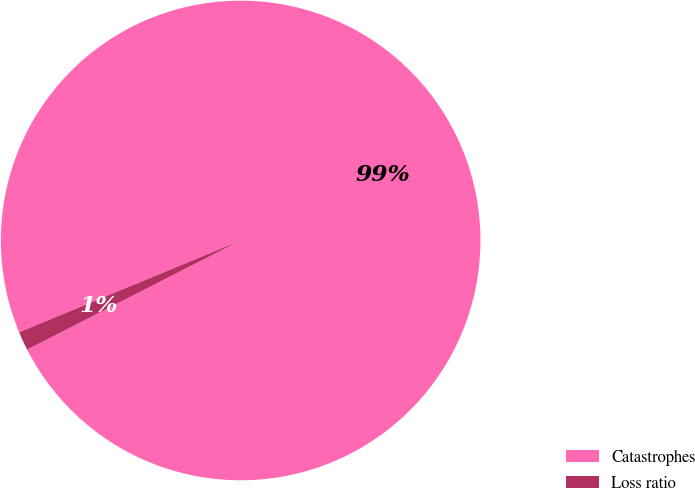Convert chart to OTSL. <chart><loc_0><loc_0><loc_500><loc_500><pie_chart><fcel>Catastrophes<fcel>Loss ratio<nl><fcel>98.73%<fcel>1.27%<nl></chart> 